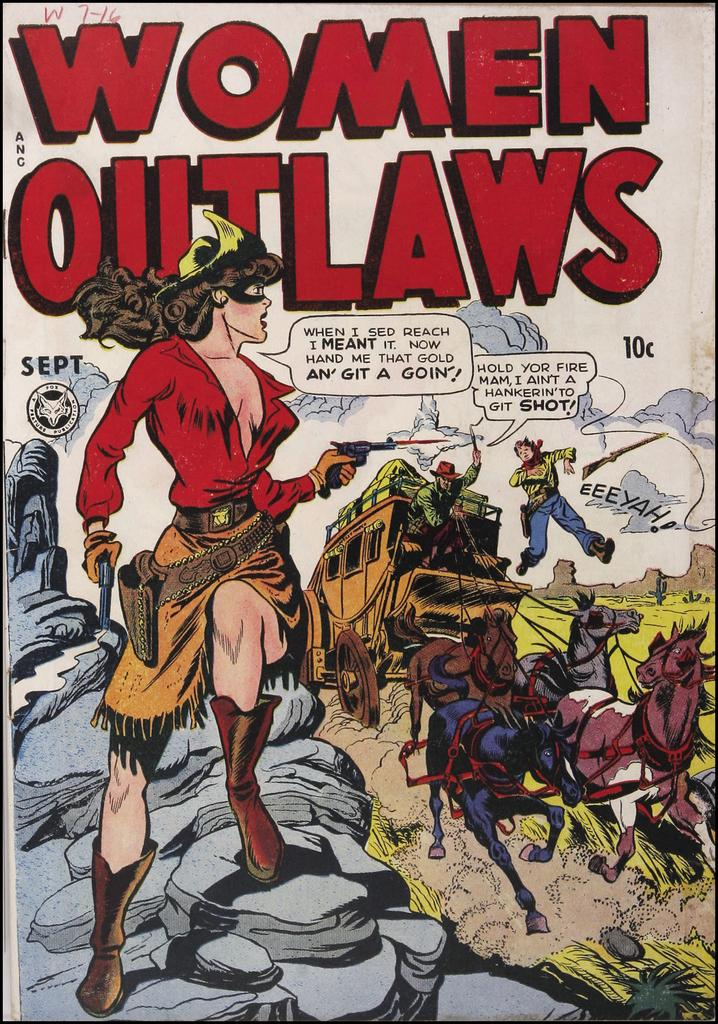<image>
Present a compact description of the photo's key features. a magazine cover that says 'woman outlaws' in red on it 